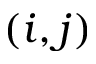Convert formula to latex. <formula><loc_0><loc_0><loc_500><loc_500>( i , j )</formula> 